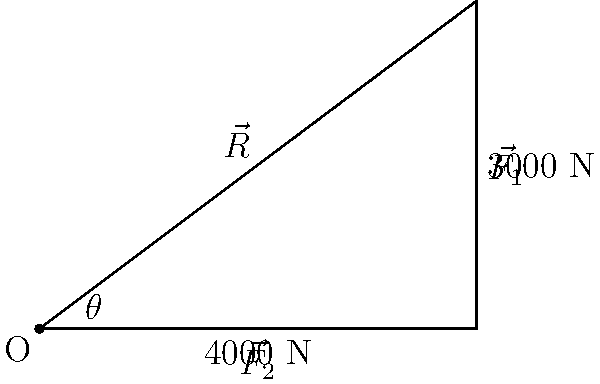A construction crane is lifting a heavy load, and two force vectors are acting on it as shown in the diagram. $\vec{F_1}$ has a magnitude of 3000 N, and $\vec{F_2}$ has a magnitude of 4000 N. What is the magnitude of the resultant force vector $\vec{R}$, which represents the maximum safe working load for this configuration? To find the magnitude of the resultant force vector $\vec{R}$, we'll use the following steps:

1. Identify the given information:
   - $\vec{F_1} = 3000$ N
   - $\vec{F_2} = 4000$ N
   - The angle between the vectors is 90° (right angle)

2. Use the Pythagorean theorem to calculate the magnitude of $\vec{R}$:
   $$|\vec{R}|^2 = |\vec{F_1}|^2 + |\vec{F_2}|^2$$

3. Substitute the known values:
   $$|\vec{R}|^2 = 3000^2 + 4000^2$$

4. Calculate the squares:
   $$|\vec{R}|^2 = 9,000,000 + 16,000,000 = 25,000,000$$

5. Take the square root of both sides:
   $$|\vec{R}| = \sqrt{25,000,000} = 5000$$

Therefore, the magnitude of the resultant force vector $\vec{R}$, which represents the maximum safe working load for this configuration, is 5000 N.
Answer: 5000 N 